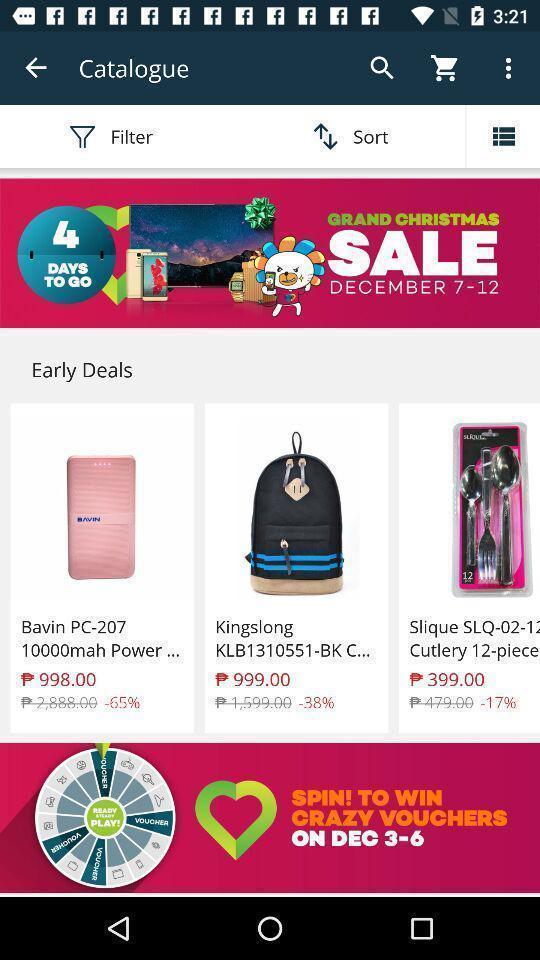Summarize the main components in this picture. Page displaying various items in shopping app. 